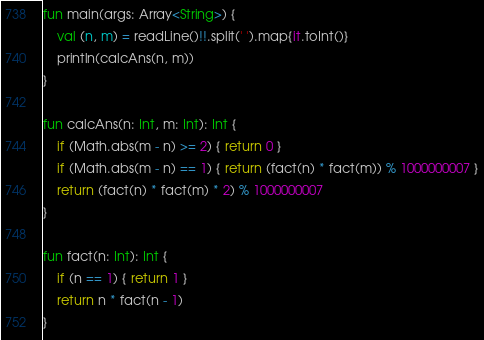Convert code to text. <code><loc_0><loc_0><loc_500><loc_500><_Kotlin_>fun main(args: Array<String>) {
    val (n, m) = readLine()!!.split(' ').map{it.toInt()}
    println(calcAns(n, m))
}

fun calcAns(n: Int, m: Int): Int {
    if (Math.abs(m - n) >= 2) { return 0 }
    if (Math.abs(m - n) == 1) { return (fact(n) * fact(m)) % 1000000007 }
    return (fact(n) * fact(m) * 2) % 1000000007
}

fun fact(n: Int): Int {
    if (n == 1) { return 1 }
    return n * fact(n - 1)
}</code> 